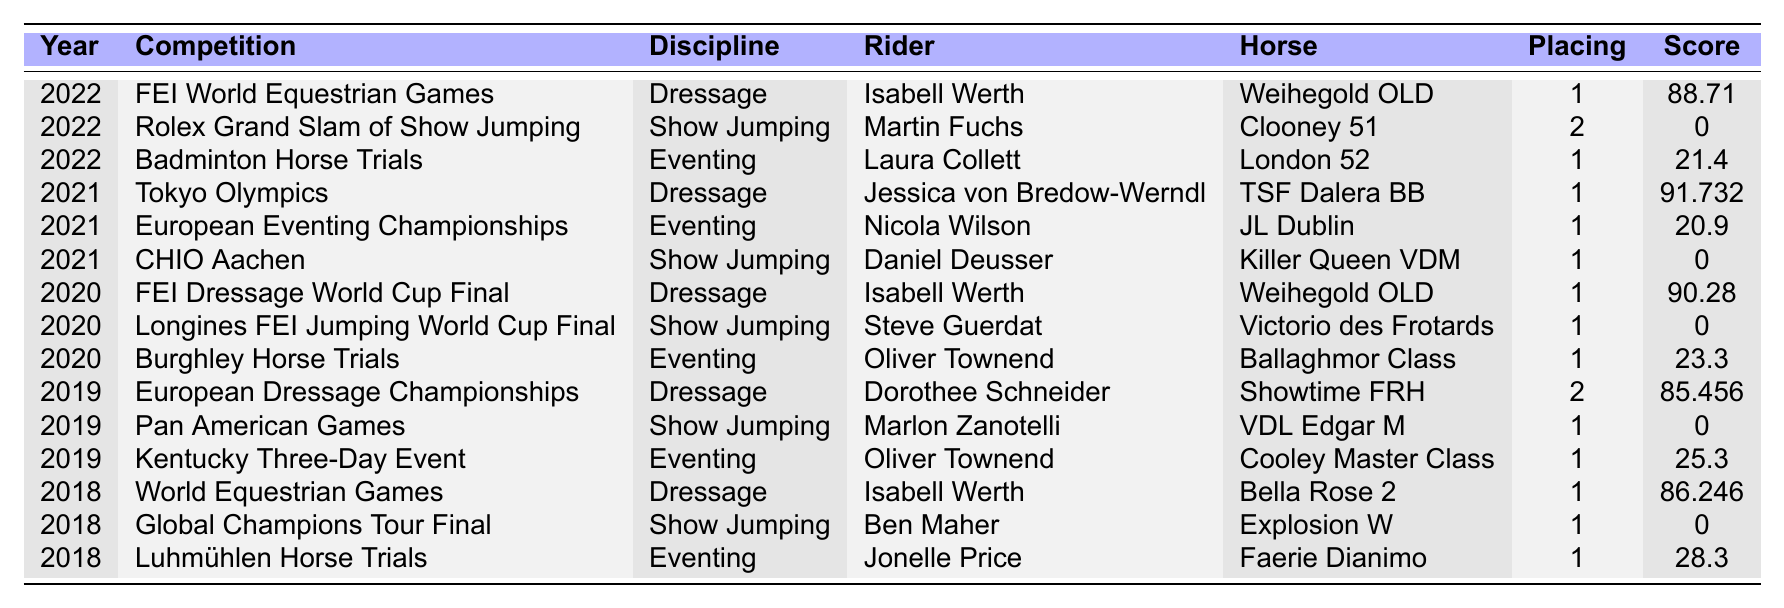What was the highest score achieved in Dressage? The table shows that the highest score in Dressage was achieved by Jessica von Bredow-Werndl in the 2021 Tokyo Olympics, with a score of 91.732.
Answer: 91.732 How many competitions are listed for the year 2020? In 2020, there are three competitions listed: FEI Dressage World Cup Final, Longines FEI Jumping World Cup Final, and Burghley Horse Trials.
Answer: 3 Who placed first in the Eventing discipline the most times? By examining the table, Oliver Townend placed first in Eventing in 2019 (Kentucky Three-Day Event) and 2020 (Burghley Horse Trials). Thus, he placed first in Eventing the most times.
Answer: Oliver Townend Is it true that Isabell Werth competed in Dressage in both 2020 and 2022? Yes, Isabell Werth competed in Dressage in both years, specifically in the 2020 FEI Dressage World Cup Final and the 2022 FEI World Equestrian Games.
Answer: Yes What is the average score of the top placements in Dressage (first place only)? The scores of the top placements in Dressage are: 88.71 (2022), 91.732 (2021), and 90.28 (2020). Summing them gives 270.732. Dividing by 3 gives an average score of 90.244.
Answer: 90.244 Which rider had the lowest score listed and in which competition did they compete? Martin Fuchs had a score of 0 in the Rolex Grand Slam of Show Jumping, which is the lowest score listed in the table.
Answer: Martin Fuchs; Rolex Grand Slam of Show Jumping How many different riders won first place in Eventing from 2018 to 2022? Analyzing the results, the first place in Eventing was won by Laura Collett (2022), Oliver Townend (2020 & 2019), and Nicola Wilson (2021). Therefore, there were three different riders who won first place.
Answer: 3 What is the total number of competitions listed in 2021? For the year 2021, there are three competitions listed: Tokyo Olympics, European Eventing Championships, and CHIO Aachen.
Answer: 3 Which discipline has the highest average score from first place results? The average scores for Dressage (91.732, 90.28, 88.71) average to 90.244; Eventing (20.9, 21.4, 25.3) average to 22.3; Show Jumping (scores are 0 for all first places). Therefore, Dressage has the highest average score.
Answer: Dressage Did any rider win first place in two different disciplines in the same year? Yes, the table shows that in 2022, Laura Collett won first place in Eventing and Isabell Werth won first place in Dressage.
Answer: Yes 